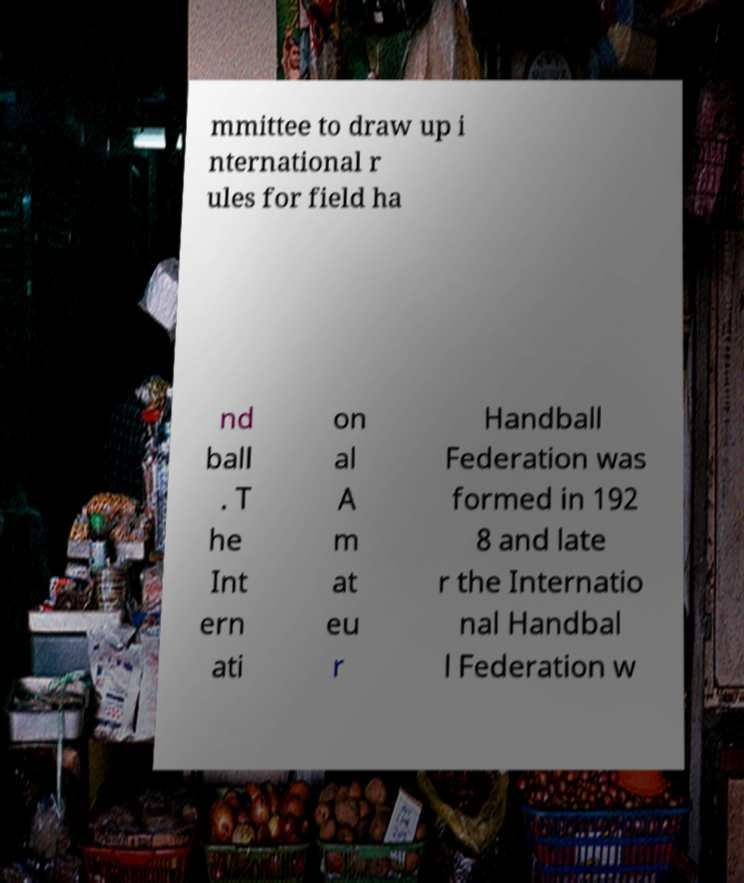For documentation purposes, I need the text within this image transcribed. Could you provide that? mmittee to draw up i nternational r ules for field ha nd ball . T he Int ern ati on al A m at eu r Handball Federation was formed in 192 8 and late r the Internatio nal Handbal l Federation w 